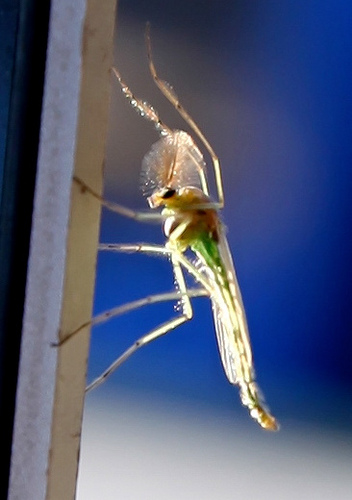<image>
Can you confirm if the bug is on the frame? Yes. Looking at the image, I can see the bug is positioned on top of the frame, with the frame providing support. 